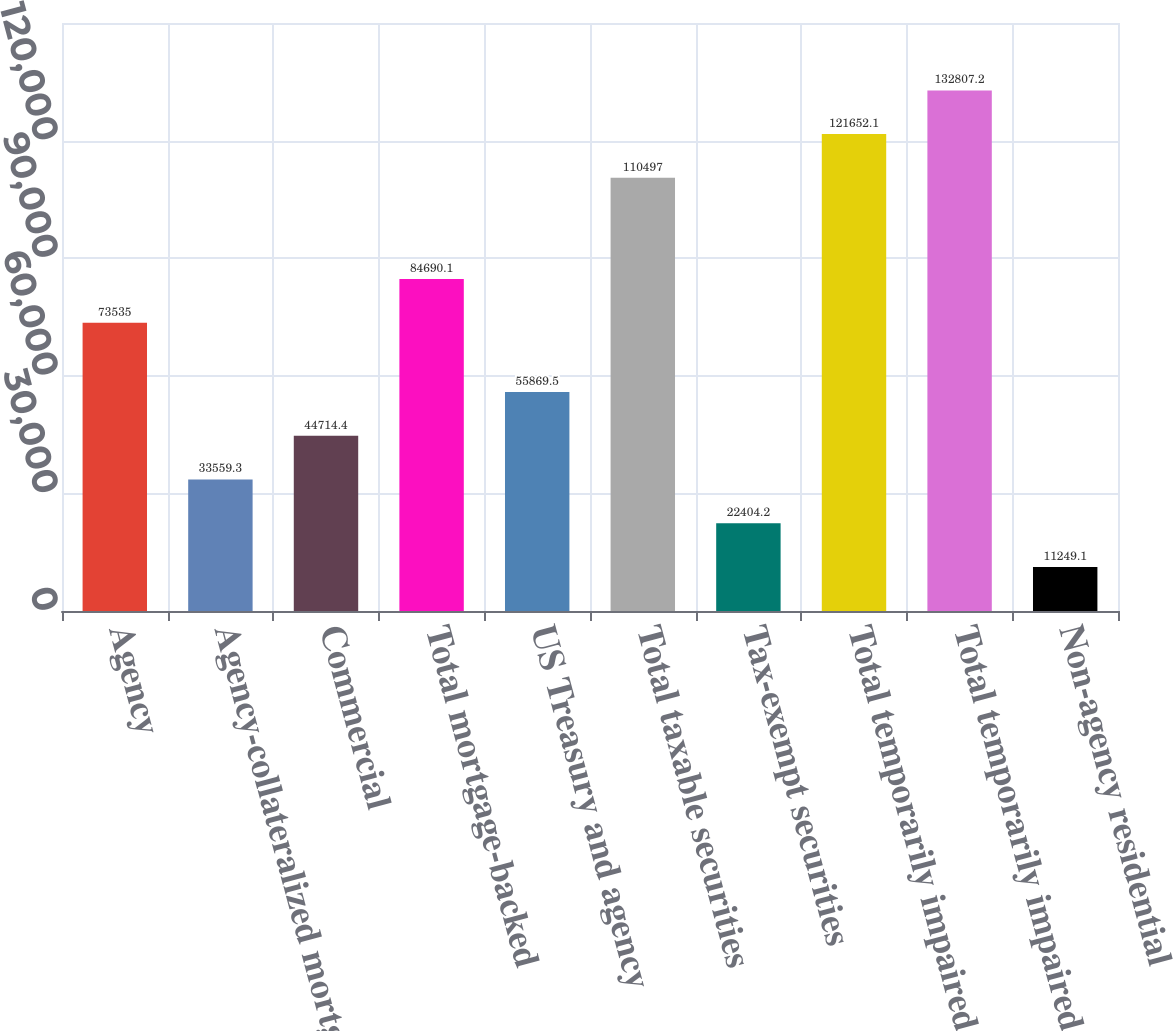<chart> <loc_0><loc_0><loc_500><loc_500><bar_chart><fcel>Agency<fcel>Agency-collateralized mortgage<fcel>Commercial<fcel>Total mortgage-backed<fcel>US Treasury and agency<fcel>Total taxable securities<fcel>Tax-exempt securities<fcel>Total temporarily impaired AFS<fcel>Total temporarily impaired and<fcel>Non-agency residential<nl><fcel>73535<fcel>33559.3<fcel>44714.4<fcel>84690.1<fcel>55869.5<fcel>110497<fcel>22404.2<fcel>121652<fcel>132807<fcel>11249.1<nl></chart> 